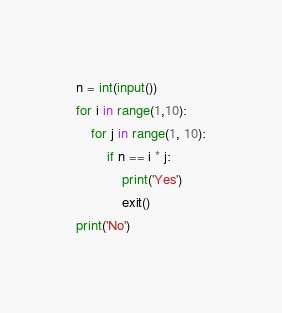<code> <loc_0><loc_0><loc_500><loc_500><_Python_>n = int(input())
for i in range(1,10):
    for j in range(1, 10):
        if n == i * j:
            print('Yes')
            exit()
print('No')</code> 